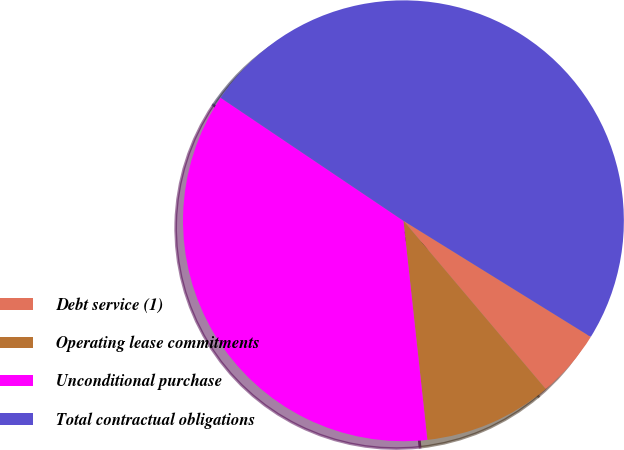Convert chart to OTSL. <chart><loc_0><loc_0><loc_500><loc_500><pie_chart><fcel>Debt service (1)<fcel>Operating lease commitments<fcel>Unconditional purchase<fcel>Total contractual obligations<nl><fcel>5.0%<fcel>9.44%<fcel>36.16%<fcel>49.4%<nl></chart> 